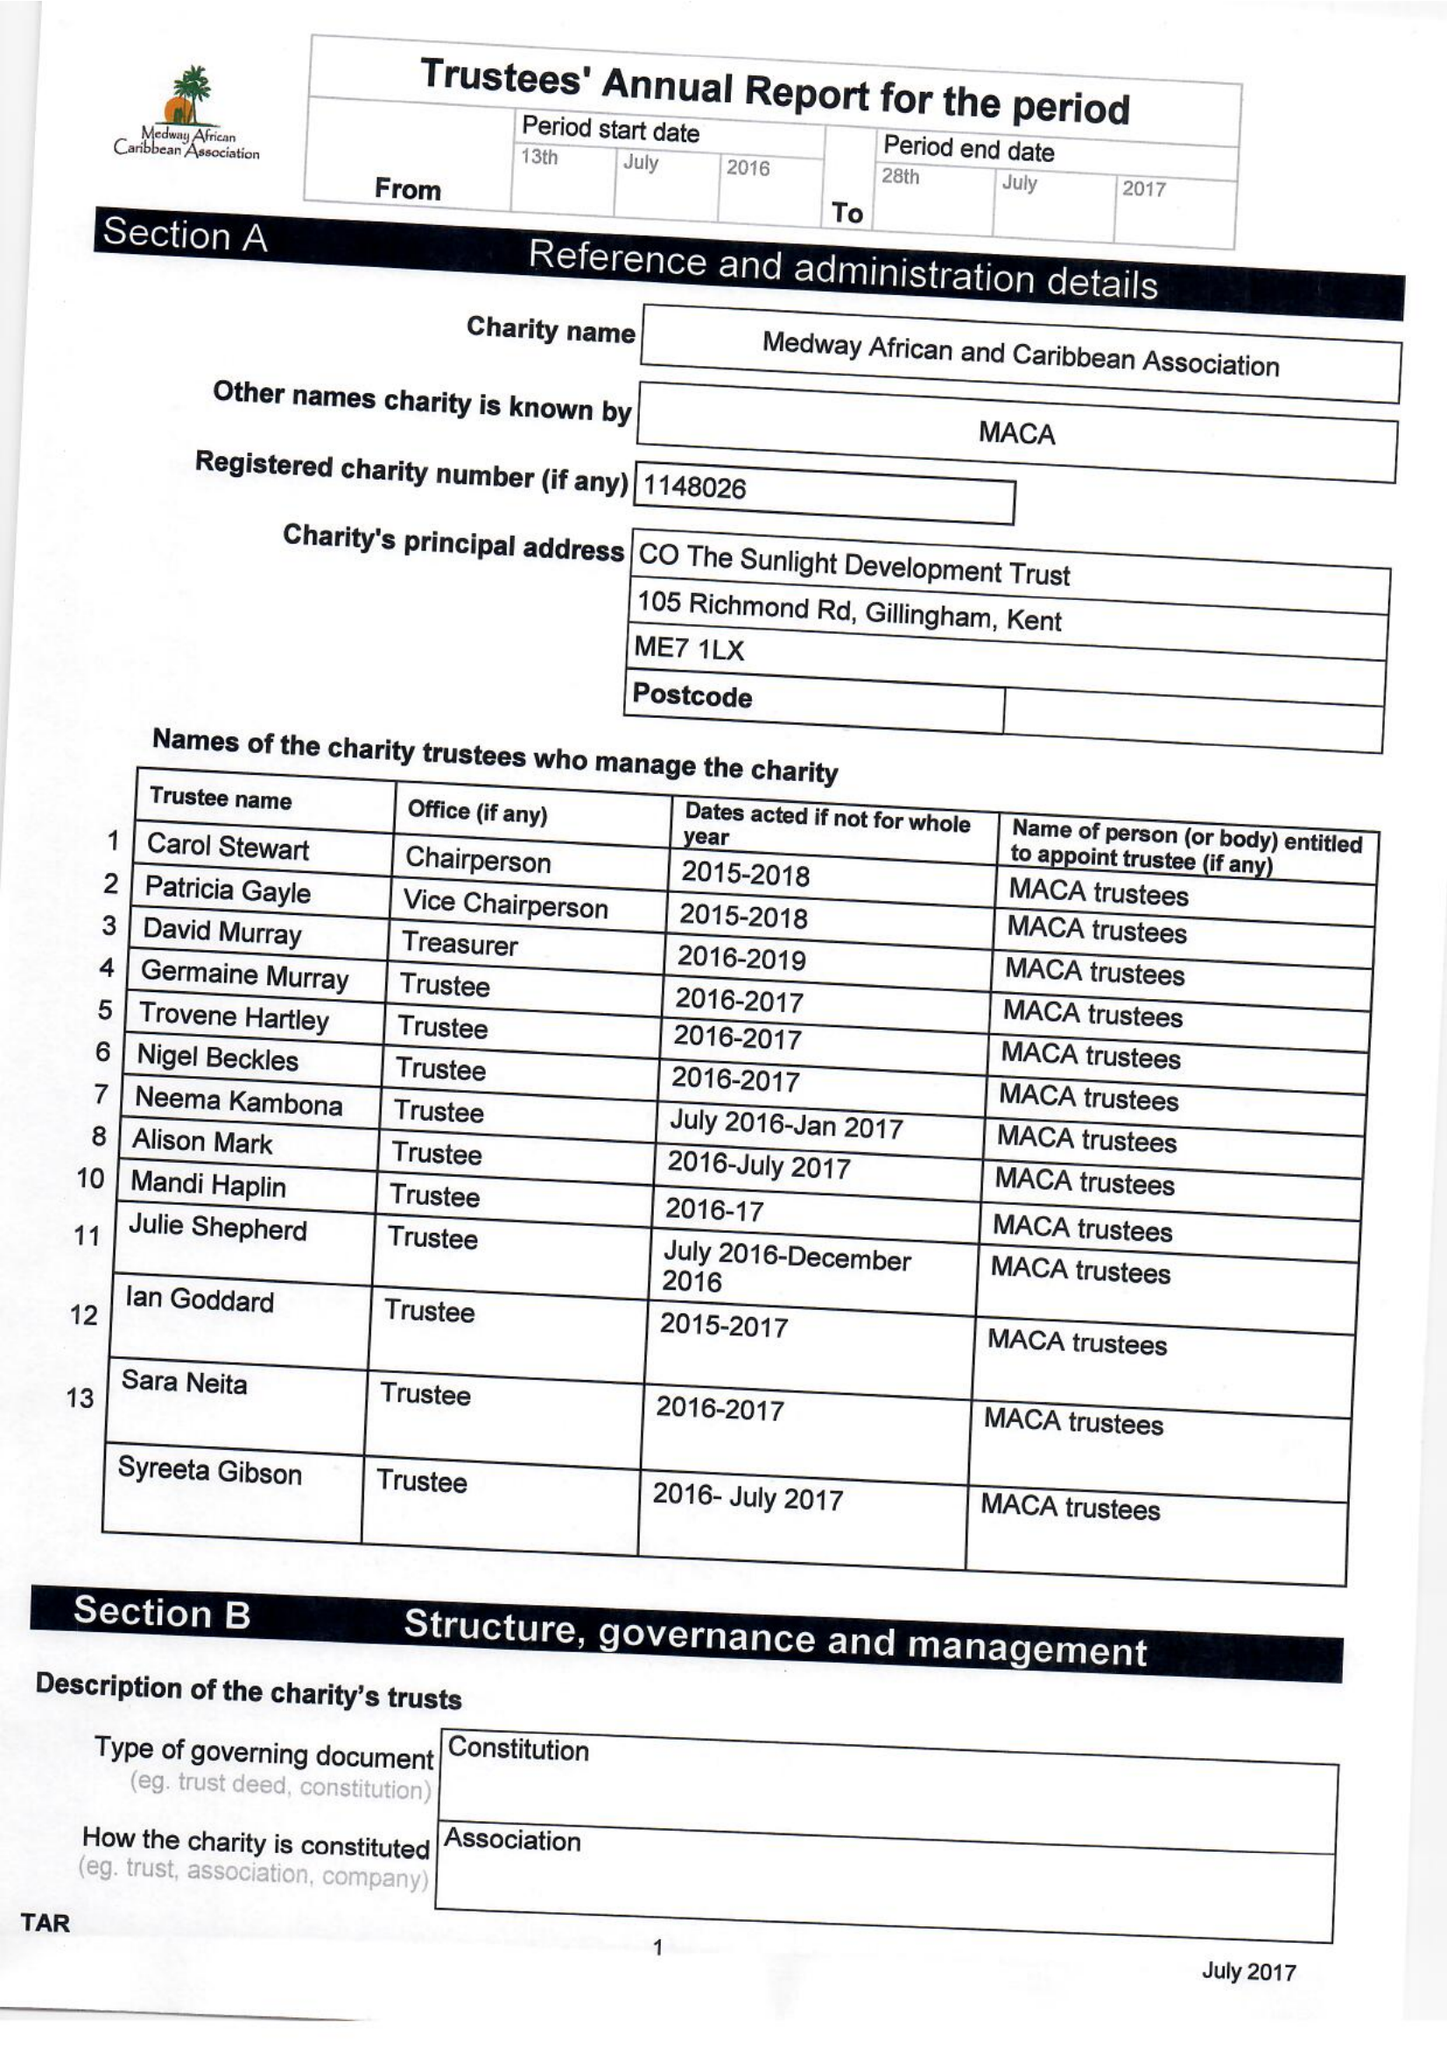What is the value for the charity_name?
Answer the question using a single word or phrase. Medway African and Caribbean Association 